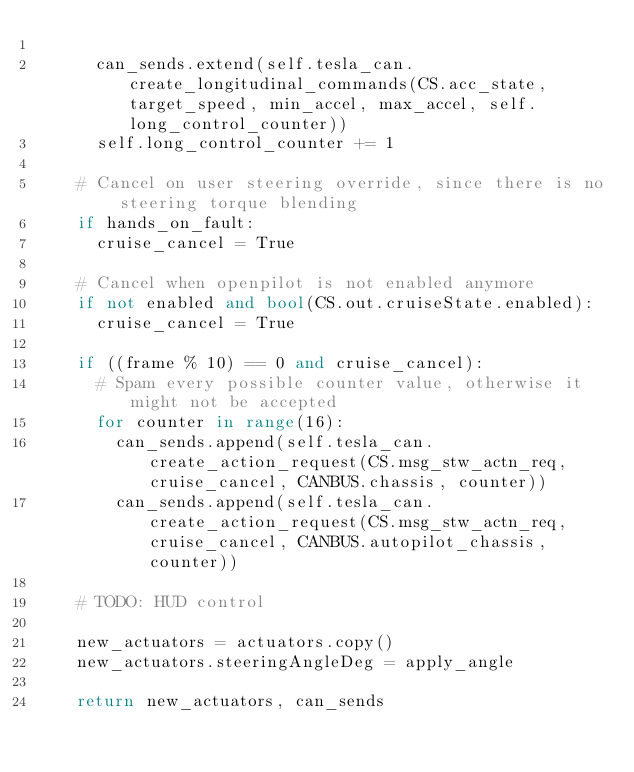<code> <loc_0><loc_0><loc_500><loc_500><_Python_>
      can_sends.extend(self.tesla_can.create_longitudinal_commands(CS.acc_state, target_speed, min_accel, max_accel, self.long_control_counter))
      self.long_control_counter += 1

    # Cancel on user steering override, since there is no steering torque blending
    if hands_on_fault:
      cruise_cancel = True

    # Cancel when openpilot is not enabled anymore
    if not enabled and bool(CS.out.cruiseState.enabled):
      cruise_cancel = True

    if ((frame % 10) == 0 and cruise_cancel):
      # Spam every possible counter value, otherwise it might not be accepted
      for counter in range(16):
        can_sends.append(self.tesla_can.create_action_request(CS.msg_stw_actn_req, cruise_cancel, CANBUS.chassis, counter))
        can_sends.append(self.tesla_can.create_action_request(CS.msg_stw_actn_req, cruise_cancel, CANBUS.autopilot_chassis, counter))

    # TODO: HUD control

    new_actuators = actuators.copy()
    new_actuators.steeringAngleDeg = apply_angle

    return new_actuators, can_sends
</code> 